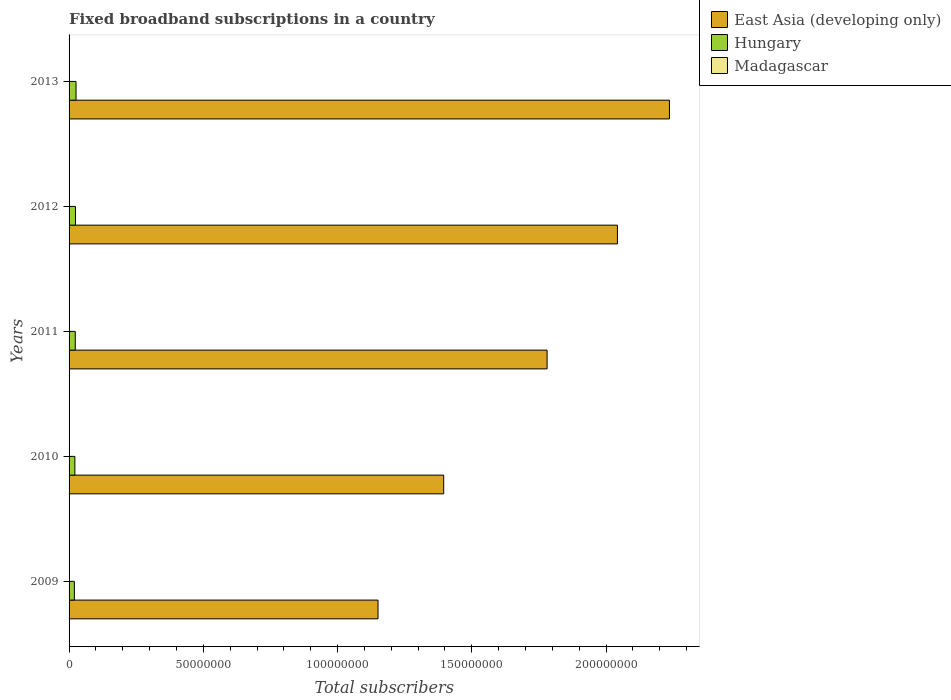How many different coloured bars are there?
Offer a terse response. 3. How many groups of bars are there?
Provide a succinct answer. 5. How many bars are there on the 4th tick from the top?
Provide a succinct answer. 3. How many bars are there on the 1st tick from the bottom?
Offer a terse response. 3. What is the label of the 1st group of bars from the top?
Offer a very short reply. 2013. In how many cases, is the number of bars for a given year not equal to the number of legend labels?
Offer a very short reply. 0. What is the number of broadband subscriptions in Madagascar in 2012?
Make the answer very short. 3.11e+04. Across all years, what is the maximum number of broadband subscriptions in Hungary?
Provide a short and direct response. 2.60e+06. Across all years, what is the minimum number of broadband subscriptions in Madagascar?
Your answer should be compact. 4576. What is the total number of broadband subscriptions in Hungary in the graph?
Offer a terse response. 1.14e+07. What is the difference between the number of broadband subscriptions in East Asia (developing only) in 2010 and that in 2013?
Make the answer very short. -8.41e+07. What is the difference between the number of broadband subscriptions in Hungary in 2010 and the number of broadband subscriptions in Madagascar in 2009?
Ensure brevity in your answer.  2.15e+06. What is the average number of broadband subscriptions in Madagascar per year?
Provide a succinct answer. 1.72e+04. In the year 2011, what is the difference between the number of broadband subscriptions in Madagascar and number of broadband subscriptions in Hungary?
Your answer should be compact. -2.31e+06. In how many years, is the number of broadband subscriptions in Madagascar greater than 130000000 ?
Offer a very short reply. 0. What is the ratio of the number of broadband subscriptions in East Asia (developing only) in 2010 to that in 2011?
Give a very brief answer. 0.78. Is the difference between the number of broadband subscriptions in Madagascar in 2011 and 2013 greater than the difference between the number of broadband subscriptions in Hungary in 2011 and 2013?
Your response must be concise. Yes. What is the difference between the highest and the second highest number of broadband subscriptions in Hungary?
Provide a succinct answer. 2.01e+05. What is the difference between the highest and the lowest number of broadband subscriptions in Hungary?
Your answer should be compact. 6.20e+05. In how many years, is the number of broadband subscriptions in Madagascar greater than the average number of broadband subscriptions in Madagascar taken over all years?
Your answer should be compact. 2. Is the sum of the number of broadband subscriptions in Hungary in 2009 and 2012 greater than the maximum number of broadband subscriptions in Madagascar across all years?
Provide a short and direct response. Yes. What does the 1st bar from the top in 2010 represents?
Your response must be concise. Madagascar. What does the 2nd bar from the bottom in 2010 represents?
Provide a short and direct response. Hungary. Is it the case that in every year, the sum of the number of broadband subscriptions in Madagascar and number of broadband subscriptions in East Asia (developing only) is greater than the number of broadband subscriptions in Hungary?
Give a very brief answer. Yes. How many years are there in the graph?
Your answer should be compact. 5. What is the difference between two consecutive major ticks on the X-axis?
Your answer should be compact. 5.00e+07. Are the values on the major ticks of X-axis written in scientific E-notation?
Offer a terse response. No. Does the graph contain any zero values?
Your response must be concise. No. Does the graph contain grids?
Your answer should be compact. No. Where does the legend appear in the graph?
Your response must be concise. Top right. How many legend labels are there?
Keep it short and to the point. 3. What is the title of the graph?
Provide a short and direct response. Fixed broadband subscriptions in a country. What is the label or title of the X-axis?
Your answer should be very brief. Total subscribers. What is the Total subscribers in East Asia (developing only) in 2009?
Make the answer very short. 1.15e+08. What is the Total subscribers of Hungary in 2009?
Make the answer very short. 1.98e+06. What is the Total subscribers of Madagascar in 2009?
Give a very brief answer. 4576. What is the Total subscribers in East Asia (developing only) in 2010?
Provide a short and direct response. 1.40e+08. What is the Total subscribers in Hungary in 2010?
Offer a terse response. 2.16e+06. What is the Total subscribers of Madagascar in 2010?
Make the answer very short. 5391. What is the Total subscribers of East Asia (developing only) in 2011?
Keep it short and to the point. 1.78e+08. What is the Total subscribers in Hungary in 2011?
Ensure brevity in your answer.  2.31e+06. What is the Total subscribers of Madagascar in 2011?
Ensure brevity in your answer.  6852. What is the Total subscribers in East Asia (developing only) in 2012?
Give a very brief answer. 2.04e+08. What is the Total subscribers in Hungary in 2012?
Your answer should be very brief. 2.40e+06. What is the Total subscribers in Madagascar in 2012?
Your answer should be compact. 3.11e+04. What is the Total subscribers of East Asia (developing only) in 2013?
Make the answer very short. 2.24e+08. What is the Total subscribers in Hungary in 2013?
Offer a terse response. 2.60e+06. What is the Total subscribers of Madagascar in 2013?
Give a very brief answer. 3.80e+04. Across all years, what is the maximum Total subscribers of East Asia (developing only)?
Ensure brevity in your answer.  2.24e+08. Across all years, what is the maximum Total subscribers of Hungary?
Offer a terse response. 2.60e+06. Across all years, what is the maximum Total subscribers in Madagascar?
Ensure brevity in your answer.  3.80e+04. Across all years, what is the minimum Total subscribers of East Asia (developing only)?
Your answer should be very brief. 1.15e+08. Across all years, what is the minimum Total subscribers in Hungary?
Provide a short and direct response. 1.98e+06. Across all years, what is the minimum Total subscribers of Madagascar?
Your answer should be compact. 4576. What is the total Total subscribers of East Asia (developing only) in the graph?
Offer a very short reply. 8.61e+08. What is the total Total subscribers of Hungary in the graph?
Keep it short and to the point. 1.14e+07. What is the total Total subscribers of Madagascar in the graph?
Your response must be concise. 8.59e+04. What is the difference between the Total subscribers of East Asia (developing only) in 2009 and that in 2010?
Offer a very short reply. -2.45e+07. What is the difference between the Total subscribers of Hungary in 2009 and that in 2010?
Give a very brief answer. -1.83e+05. What is the difference between the Total subscribers of Madagascar in 2009 and that in 2010?
Provide a succinct answer. -815. What is the difference between the Total subscribers in East Asia (developing only) in 2009 and that in 2011?
Your answer should be compact. -6.30e+07. What is the difference between the Total subscribers of Hungary in 2009 and that in 2011?
Your response must be concise. -3.36e+05. What is the difference between the Total subscribers of Madagascar in 2009 and that in 2011?
Offer a terse response. -2276. What is the difference between the Total subscribers in East Asia (developing only) in 2009 and that in 2012?
Give a very brief answer. -8.92e+07. What is the difference between the Total subscribers of Hungary in 2009 and that in 2012?
Provide a short and direct response. -4.19e+05. What is the difference between the Total subscribers in Madagascar in 2009 and that in 2012?
Offer a very short reply. -2.65e+04. What is the difference between the Total subscribers in East Asia (developing only) in 2009 and that in 2013?
Ensure brevity in your answer.  -1.09e+08. What is the difference between the Total subscribers of Hungary in 2009 and that in 2013?
Ensure brevity in your answer.  -6.20e+05. What is the difference between the Total subscribers in Madagascar in 2009 and that in 2013?
Offer a terse response. -3.34e+04. What is the difference between the Total subscribers of East Asia (developing only) in 2010 and that in 2011?
Your answer should be very brief. -3.85e+07. What is the difference between the Total subscribers of Hungary in 2010 and that in 2011?
Your answer should be compact. -1.54e+05. What is the difference between the Total subscribers of Madagascar in 2010 and that in 2011?
Offer a terse response. -1461. What is the difference between the Total subscribers in East Asia (developing only) in 2010 and that in 2012?
Your answer should be very brief. -6.47e+07. What is the difference between the Total subscribers of Hungary in 2010 and that in 2012?
Offer a terse response. -2.37e+05. What is the difference between the Total subscribers of Madagascar in 2010 and that in 2012?
Offer a very short reply. -2.57e+04. What is the difference between the Total subscribers of East Asia (developing only) in 2010 and that in 2013?
Make the answer very short. -8.41e+07. What is the difference between the Total subscribers of Hungary in 2010 and that in 2013?
Ensure brevity in your answer.  -4.38e+05. What is the difference between the Total subscribers of Madagascar in 2010 and that in 2013?
Give a very brief answer. -3.26e+04. What is the difference between the Total subscribers of East Asia (developing only) in 2011 and that in 2012?
Offer a terse response. -2.62e+07. What is the difference between the Total subscribers in Hungary in 2011 and that in 2012?
Ensure brevity in your answer.  -8.29e+04. What is the difference between the Total subscribers in Madagascar in 2011 and that in 2012?
Provide a short and direct response. -2.42e+04. What is the difference between the Total subscribers of East Asia (developing only) in 2011 and that in 2013?
Your response must be concise. -4.56e+07. What is the difference between the Total subscribers of Hungary in 2011 and that in 2013?
Give a very brief answer. -2.84e+05. What is the difference between the Total subscribers in Madagascar in 2011 and that in 2013?
Your answer should be very brief. -3.11e+04. What is the difference between the Total subscribers in East Asia (developing only) in 2012 and that in 2013?
Keep it short and to the point. -1.94e+07. What is the difference between the Total subscribers of Hungary in 2012 and that in 2013?
Give a very brief answer. -2.01e+05. What is the difference between the Total subscribers in Madagascar in 2012 and that in 2013?
Your response must be concise. -6911. What is the difference between the Total subscribers in East Asia (developing only) in 2009 and the Total subscribers in Hungary in 2010?
Your response must be concise. 1.13e+08. What is the difference between the Total subscribers in East Asia (developing only) in 2009 and the Total subscribers in Madagascar in 2010?
Offer a terse response. 1.15e+08. What is the difference between the Total subscribers in Hungary in 2009 and the Total subscribers in Madagascar in 2010?
Your response must be concise. 1.97e+06. What is the difference between the Total subscribers in East Asia (developing only) in 2009 and the Total subscribers in Hungary in 2011?
Ensure brevity in your answer.  1.13e+08. What is the difference between the Total subscribers in East Asia (developing only) in 2009 and the Total subscribers in Madagascar in 2011?
Provide a succinct answer. 1.15e+08. What is the difference between the Total subscribers in Hungary in 2009 and the Total subscribers in Madagascar in 2011?
Give a very brief answer. 1.97e+06. What is the difference between the Total subscribers in East Asia (developing only) in 2009 and the Total subscribers in Hungary in 2012?
Provide a succinct answer. 1.13e+08. What is the difference between the Total subscribers of East Asia (developing only) in 2009 and the Total subscribers of Madagascar in 2012?
Provide a short and direct response. 1.15e+08. What is the difference between the Total subscribers of Hungary in 2009 and the Total subscribers of Madagascar in 2012?
Give a very brief answer. 1.95e+06. What is the difference between the Total subscribers of East Asia (developing only) in 2009 and the Total subscribers of Hungary in 2013?
Keep it short and to the point. 1.12e+08. What is the difference between the Total subscribers in East Asia (developing only) in 2009 and the Total subscribers in Madagascar in 2013?
Your answer should be compact. 1.15e+08. What is the difference between the Total subscribers of Hungary in 2009 and the Total subscribers of Madagascar in 2013?
Ensure brevity in your answer.  1.94e+06. What is the difference between the Total subscribers of East Asia (developing only) in 2010 and the Total subscribers of Hungary in 2011?
Your answer should be very brief. 1.37e+08. What is the difference between the Total subscribers of East Asia (developing only) in 2010 and the Total subscribers of Madagascar in 2011?
Your answer should be very brief. 1.40e+08. What is the difference between the Total subscribers of Hungary in 2010 and the Total subscribers of Madagascar in 2011?
Provide a short and direct response. 2.15e+06. What is the difference between the Total subscribers in East Asia (developing only) in 2010 and the Total subscribers in Hungary in 2012?
Provide a short and direct response. 1.37e+08. What is the difference between the Total subscribers in East Asia (developing only) in 2010 and the Total subscribers in Madagascar in 2012?
Your response must be concise. 1.40e+08. What is the difference between the Total subscribers in Hungary in 2010 and the Total subscribers in Madagascar in 2012?
Offer a terse response. 2.13e+06. What is the difference between the Total subscribers in East Asia (developing only) in 2010 and the Total subscribers in Hungary in 2013?
Offer a very short reply. 1.37e+08. What is the difference between the Total subscribers in East Asia (developing only) in 2010 and the Total subscribers in Madagascar in 2013?
Ensure brevity in your answer.  1.39e+08. What is the difference between the Total subscribers in Hungary in 2010 and the Total subscribers in Madagascar in 2013?
Make the answer very short. 2.12e+06. What is the difference between the Total subscribers of East Asia (developing only) in 2011 and the Total subscribers of Hungary in 2012?
Offer a very short reply. 1.76e+08. What is the difference between the Total subscribers of East Asia (developing only) in 2011 and the Total subscribers of Madagascar in 2012?
Your response must be concise. 1.78e+08. What is the difference between the Total subscribers in Hungary in 2011 and the Total subscribers in Madagascar in 2012?
Ensure brevity in your answer.  2.28e+06. What is the difference between the Total subscribers in East Asia (developing only) in 2011 and the Total subscribers in Hungary in 2013?
Give a very brief answer. 1.75e+08. What is the difference between the Total subscribers in East Asia (developing only) in 2011 and the Total subscribers in Madagascar in 2013?
Offer a very short reply. 1.78e+08. What is the difference between the Total subscribers in Hungary in 2011 and the Total subscribers in Madagascar in 2013?
Offer a terse response. 2.28e+06. What is the difference between the Total subscribers of East Asia (developing only) in 2012 and the Total subscribers of Hungary in 2013?
Provide a short and direct response. 2.02e+08. What is the difference between the Total subscribers in East Asia (developing only) in 2012 and the Total subscribers in Madagascar in 2013?
Make the answer very short. 2.04e+08. What is the difference between the Total subscribers of Hungary in 2012 and the Total subscribers of Madagascar in 2013?
Make the answer very short. 2.36e+06. What is the average Total subscribers of East Asia (developing only) per year?
Your response must be concise. 1.72e+08. What is the average Total subscribers in Hungary per year?
Offer a very short reply. 2.29e+06. What is the average Total subscribers of Madagascar per year?
Your response must be concise. 1.72e+04. In the year 2009, what is the difference between the Total subscribers in East Asia (developing only) and Total subscribers in Hungary?
Your answer should be very brief. 1.13e+08. In the year 2009, what is the difference between the Total subscribers in East Asia (developing only) and Total subscribers in Madagascar?
Your response must be concise. 1.15e+08. In the year 2009, what is the difference between the Total subscribers of Hungary and Total subscribers of Madagascar?
Ensure brevity in your answer.  1.97e+06. In the year 2010, what is the difference between the Total subscribers in East Asia (developing only) and Total subscribers in Hungary?
Ensure brevity in your answer.  1.37e+08. In the year 2010, what is the difference between the Total subscribers of East Asia (developing only) and Total subscribers of Madagascar?
Provide a succinct answer. 1.40e+08. In the year 2010, what is the difference between the Total subscribers of Hungary and Total subscribers of Madagascar?
Offer a terse response. 2.15e+06. In the year 2011, what is the difference between the Total subscribers in East Asia (developing only) and Total subscribers in Hungary?
Your answer should be compact. 1.76e+08. In the year 2011, what is the difference between the Total subscribers in East Asia (developing only) and Total subscribers in Madagascar?
Your response must be concise. 1.78e+08. In the year 2011, what is the difference between the Total subscribers in Hungary and Total subscribers in Madagascar?
Offer a very short reply. 2.31e+06. In the year 2012, what is the difference between the Total subscribers in East Asia (developing only) and Total subscribers in Hungary?
Make the answer very short. 2.02e+08. In the year 2012, what is the difference between the Total subscribers of East Asia (developing only) and Total subscribers of Madagascar?
Make the answer very short. 2.04e+08. In the year 2012, what is the difference between the Total subscribers in Hungary and Total subscribers in Madagascar?
Give a very brief answer. 2.36e+06. In the year 2013, what is the difference between the Total subscribers in East Asia (developing only) and Total subscribers in Hungary?
Provide a succinct answer. 2.21e+08. In the year 2013, what is the difference between the Total subscribers in East Asia (developing only) and Total subscribers in Madagascar?
Your answer should be very brief. 2.24e+08. In the year 2013, what is the difference between the Total subscribers in Hungary and Total subscribers in Madagascar?
Make the answer very short. 2.56e+06. What is the ratio of the Total subscribers in East Asia (developing only) in 2009 to that in 2010?
Your response must be concise. 0.82. What is the ratio of the Total subscribers in Hungary in 2009 to that in 2010?
Keep it short and to the point. 0.92. What is the ratio of the Total subscribers of Madagascar in 2009 to that in 2010?
Ensure brevity in your answer.  0.85. What is the ratio of the Total subscribers in East Asia (developing only) in 2009 to that in 2011?
Give a very brief answer. 0.65. What is the ratio of the Total subscribers in Hungary in 2009 to that in 2011?
Offer a terse response. 0.85. What is the ratio of the Total subscribers in Madagascar in 2009 to that in 2011?
Provide a short and direct response. 0.67. What is the ratio of the Total subscribers in East Asia (developing only) in 2009 to that in 2012?
Offer a terse response. 0.56. What is the ratio of the Total subscribers of Hungary in 2009 to that in 2012?
Your answer should be very brief. 0.82. What is the ratio of the Total subscribers in Madagascar in 2009 to that in 2012?
Your answer should be very brief. 0.15. What is the ratio of the Total subscribers of East Asia (developing only) in 2009 to that in 2013?
Keep it short and to the point. 0.51. What is the ratio of the Total subscribers of Hungary in 2009 to that in 2013?
Keep it short and to the point. 0.76. What is the ratio of the Total subscribers of Madagascar in 2009 to that in 2013?
Your answer should be very brief. 0.12. What is the ratio of the Total subscribers in East Asia (developing only) in 2010 to that in 2011?
Keep it short and to the point. 0.78. What is the ratio of the Total subscribers in Hungary in 2010 to that in 2011?
Your response must be concise. 0.93. What is the ratio of the Total subscribers in Madagascar in 2010 to that in 2011?
Your answer should be compact. 0.79. What is the ratio of the Total subscribers of East Asia (developing only) in 2010 to that in 2012?
Offer a terse response. 0.68. What is the ratio of the Total subscribers of Hungary in 2010 to that in 2012?
Offer a very short reply. 0.9. What is the ratio of the Total subscribers of Madagascar in 2010 to that in 2012?
Your answer should be very brief. 0.17. What is the ratio of the Total subscribers of East Asia (developing only) in 2010 to that in 2013?
Your answer should be very brief. 0.62. What is the ratio of the Total subscribers of Hungary in 2010 to that in 2013?
Make the answer very short. 0.83. What is the ratio of the Total subscribers in Madagascar in 2010 to that in 2013?
Provide a succinct answer. 0.14. What is the ratio of the Total subscribers of East Asia (developing only) in 2011 to that in 2012?
Give a very brief answer. 0.87. What is the ratio of the Total subscribers in Hungary in 2011 to that in 2012?
Keep it short and to the point. 0.97. What is the ratio of the Total subscribers of Madagascar in 2011 to that in 2012?
Make the answer very short. 0.22. What is the ratio of the Total subscribers in East Asia (developing only) in 2011 to that in 2013?
Your answer should be very brief. 0.8. What is the ratio of the Total subscribers of Hungary in 2011 to that in 2013?
Your response must be concise. 0.89. What is the ratio of the Total subscribers of Madagascar in 2011 to that in 2013?
Your response must be concise. 0.18. What is the ratio of the Total subscribers of East Asia (developing only) in 2012 to that in 2013?
Provide a succinct answer. 0.91. What is the ratio of the Total subscribers in Hungary in 2012 to that in 2013?
Your answer should be compact. 0.92. What is the ratio of the Total subscribers in Madagascar in 2012 to that in 2013?
Provide a succinct answer. 0.82. What is the difference between the highest and the second highest Total subscribers in East Asia (developing only)?
Provide a short and direct response. 1.94e+07. What is the difference between the highest and the second highest Total subscribers of Hungary?
Your answer should be compact. 2.01e+05. What is the difference between the highest and the second highest Total subscribers of Madagascar?
Make the answer very short. 6911. What is the difference between the highest and the lowest Total subscribers in East Asia (developing only)?
Make the answer very short. 1.09e+08. What is the difference between the highest and the lowest Total subscribers of Hungary?
Your answer should be very brief. 6.20e+05. What is the difference between the highest and the lowest Total subscribers in Madagascar?
Your answer should be very brief. 3.34e+04. 